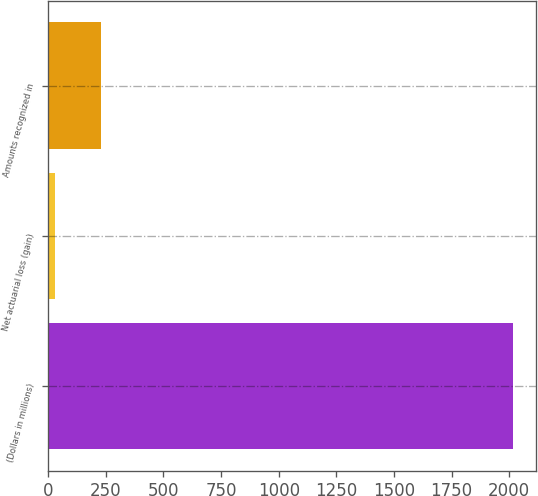<chart> <loc_0><loc_0><loc_500><loc_500><bar_chart><fcel>(Dollars in millions)<fcel>Net actuarial loss (gain)<fcel>Amounts recognized in<nl><fcel>2017<fcel>30<fcel>228.7<nl></chart> 